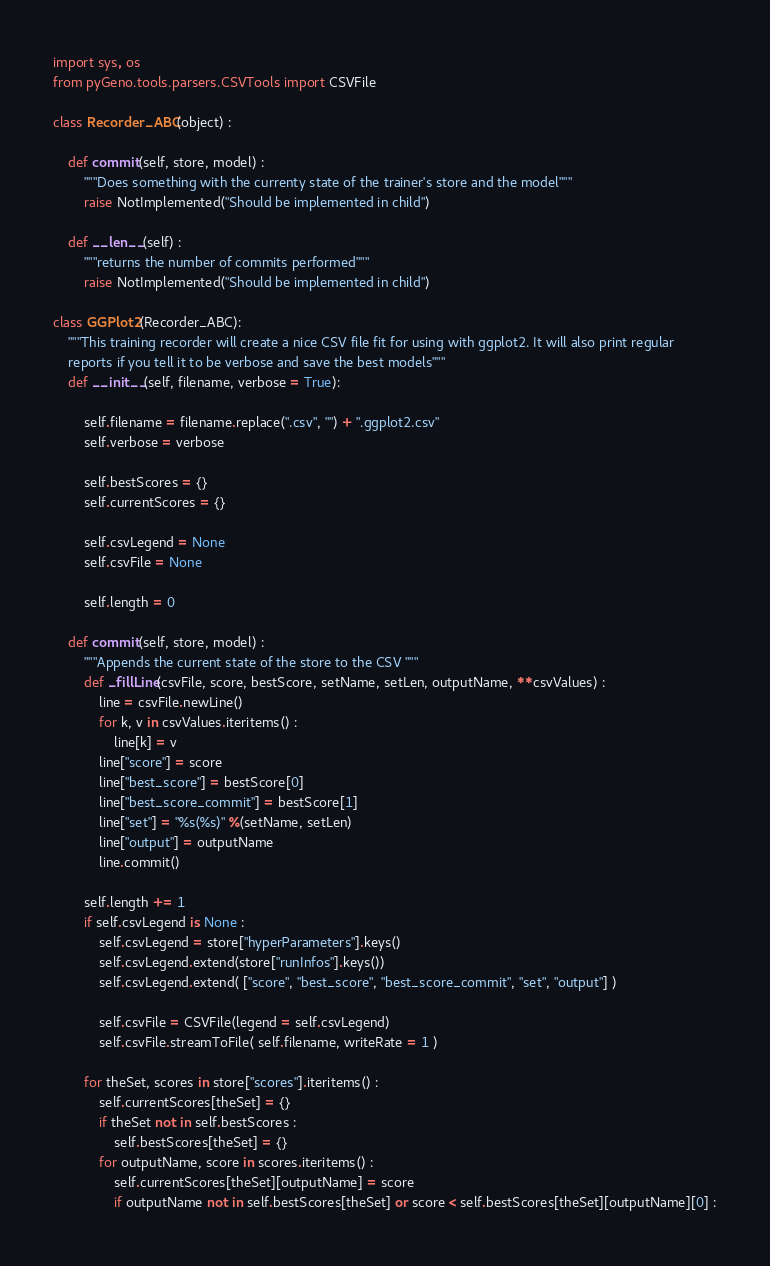<code> <loc_0><loc_0><loc_500><loc_500><_Python_>import sys, os
from pyGeno.tools.parsers.CSVTools import CSVFile

class Recorder_ABC(object) :

	def commit(self, store, model) :
		"""Does something with the currenty state of the trainer's store and the model"""
		raise NotImplemented("Should be implemented in child")

	def __len__(self) :
		"""returns the number of commits performed"""
		raise NotImplemented("Should be implemented in child")

class GGPlot2(Recorder_ABC):
 	"""This training recorder will create a nice CSV file fit for using with ggplot2. It will also print regular
 	reports if you tell it to be verbose and save the best models"""
 	def __init__(self, filename, verbose = True):
		
		self.filename = filename.replace(".csv", "") + ".ggplot2.csv"
		self.verbose = verbose
	
 		self.bestScores = {}
		self.currentScores = {}

		self.csvLegend = None
		self.csvFile = None

		self.length = 0

	def commit(self, store, model) :
		"""Appends the current state of the store to the CSV """
		def _fillLine(csvFile, score, bestScore, setName, setLen, outputName, **csvValues) :
			line = csvFile.newLine()
			for k, v in csvValues.iteritems() :
				line[k] = v
			line["score"] = score
			line["best_score"] = bestScore[0]
			line["best_score_commit"] = bestScore[1]
			line["set"] = "%s(%s)" %(setName, setLen)
			line["output"] = outputName
			line.commit()
		
		self.length += 1
		if self.csvLegend is None :
			self.csvLegend = store["hyperParameters"].keys()
			self.csvLegend.extend(store["runInfos"].keys())
			self.csvLegend.extend( ["score", "best_score", "best_score_commit", "set", "output"] )

			self.csvFile = CSVFile(legend = self.csvLegend)
			self.csvFile.streamToFile( self.filename, writeRate = 1 )

		for theSet, scores in store["scores"].iteritems() :
			self.currentScores[theSet] = {}
			if theSet not in self.bestScores :
				self.bestScores[theSet] = {}
			for outputName, score in scores.iteritems() :
				self.currentScores[theSet][outputName] = score
				if outputName not in self.bestScores[theSet] or score < self.bestScores[theSet][outputName][0] :</code> 